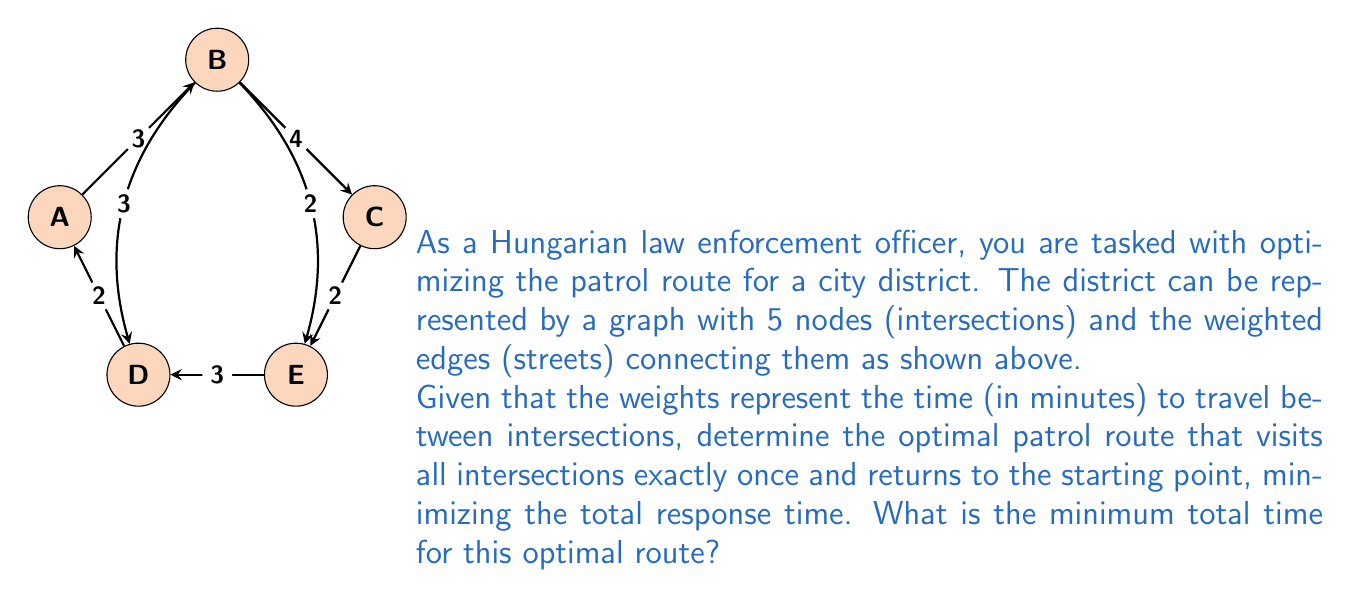Show me your answer to this math problem. To solve this problem, we need to find the Hamiltonian cycle with the minimum total weight in the given graph. This is known as the Traveling Salesman Problem (TSP).

For a small graph like this, we can use a brute-force approach to find the optimal solution:

1. List all possible Hamiltonian cycles:
   A-B-C-E-D-A
   A-B-D-E-C-A
   A-B-E-C-D-A
   A-B-E-D-C-A
   A-D-B-C-E-A
   A-D-B-E-C-A
   A-D-E-B-C-A
   A-D-E-C-B-A

2. Calculate the total time for each cycle:
   A-B-C-E-D-A: 3 + 4 + 2 + 3 + 2 = 14 minutes
   A-B-D-E-C-A: 3 + 3 + 3 + 2 + 4 = 15 minutes
   A-B-E-C-D-A: 3 + 2 + 2 + 3 + 2 = 12 minutes
   A-B-E-D-C-A: 3 + 2 + 3 + 3 + 4 = 15 minutes
   A-D-B-C-E-A: 2 + 3 + 4 + 2 + 2 = 13 minutes
   A-D-B-E-C-A: 2 + 3 + 2 + 2 + 4 = 13 minutes
   A-D-E-B-C-A: 2 + 3 + 2 + 4 + 4 = 15 minutes
   A-D-E-C-B-A: 2 + 3 + 2 + 4 + 3 = 14 minutes

3. Identify the cycle with the minimum total time:
   The optimal route is A-B-E-C-D-A with a total time of 12 minutes.

This brute-force method works for small graphs, but for larger networks, more efficient algorithms like the Held-Karp algorithm or heuristic methods would be necessary.
Answer: 12 minutes 